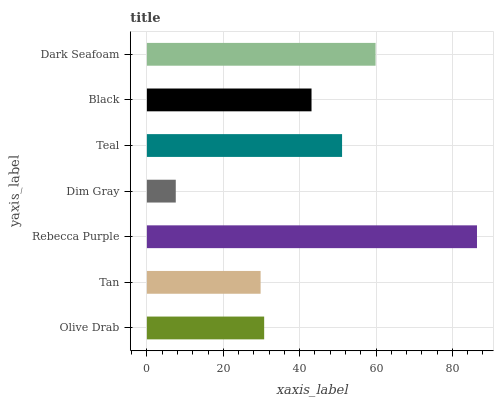Is Dim Gray the minimum?
Answer yes or no. Yes. Is Rebecca Purple the maximum?
Answer yes or no. Yes. Is Tan the minimum?
Answer yes or no. No. Is Tan the maximum?
Answer yes or no. No. Is Olive Drab greater than Tan?
Answer yes or no. Yes. Is Tan less than Olive Drab?
Answer yes or no. Yes. Is Tan greater than Olive Drab?
Answer yes or no. No. Is Olive Drab less than Tan?
Answer yes or no. No. Is Black the high median?
Answer yes or no. Yes. Is Black the low median?
Answer yes or no. Yes. Is Rebecca Purple the high median?
Answer yes or no. No. Is Rebecca Purple the low median?
Answer yes or no. No. 